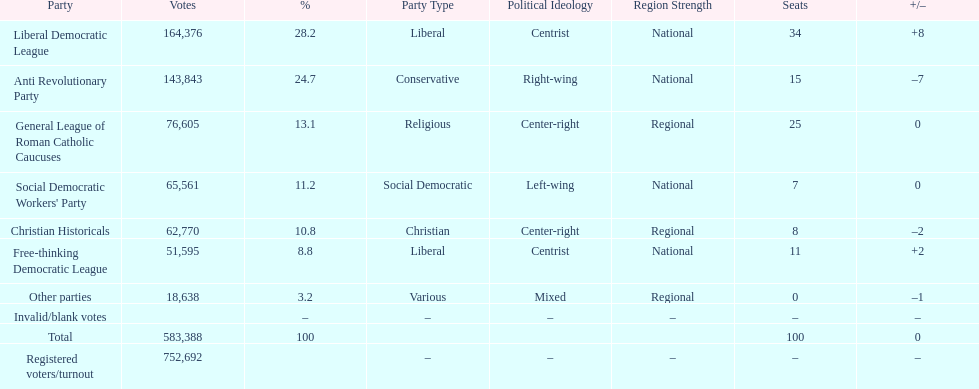After the election, how many seats did the liberal democratic league win? 34. 